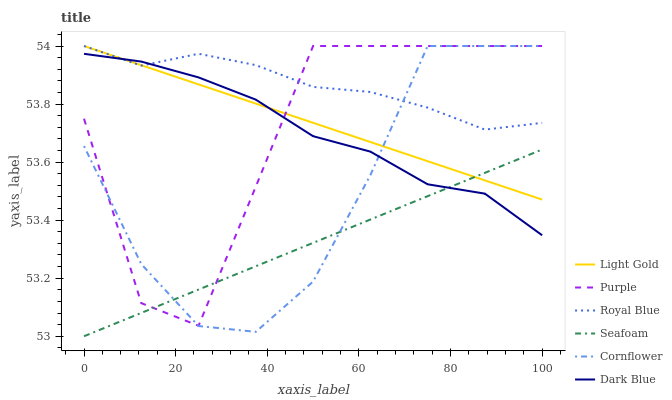Does Seafoam have the minimum area under the curve?
Answer yes or no. Yes. Does Royal Blue have the maximum area under the curve?
Answer yes or no. Yes. Does Dark Blue have the minimum area under the curve?
Answer yes or no. No. Does Dark Blue have the maximum area under the curve?
Answer yes or no. No. Is Seafoam the smoothest?
Answer yes or no. Yes. Is Purple the roughest?
Answer yes or no. Yes. Is Dark Blue the smoothest?
Answer yes or no. No. Is Dark Blue the roughest?
Answer yes or no. No. Does Seafoam have the lowest value?
Answer yes or no. Yes. Does Dark Blue have the lowest value?
Answer yes or no. No. Does Light Gold have the highest value?
Answer yes or no. Yes. Does Dark Blue have the highest value?
Answer yes or no. No. Is Seafoam less than Royal Blue?
Answer yes or no. Yes. Is Royal Blue greater than Seafoam?
Answer yes or no. Yes. Does Royal Blue intersect Purple?
Answer yes or no. Yes. Is Royal Blue less than Purple?
Answer yes or no. No. Is Royal Blue greater than Purple?
Answer yes or no. No. Does Seafoam intersect Royal Blue?
Answer yes or no. No. 